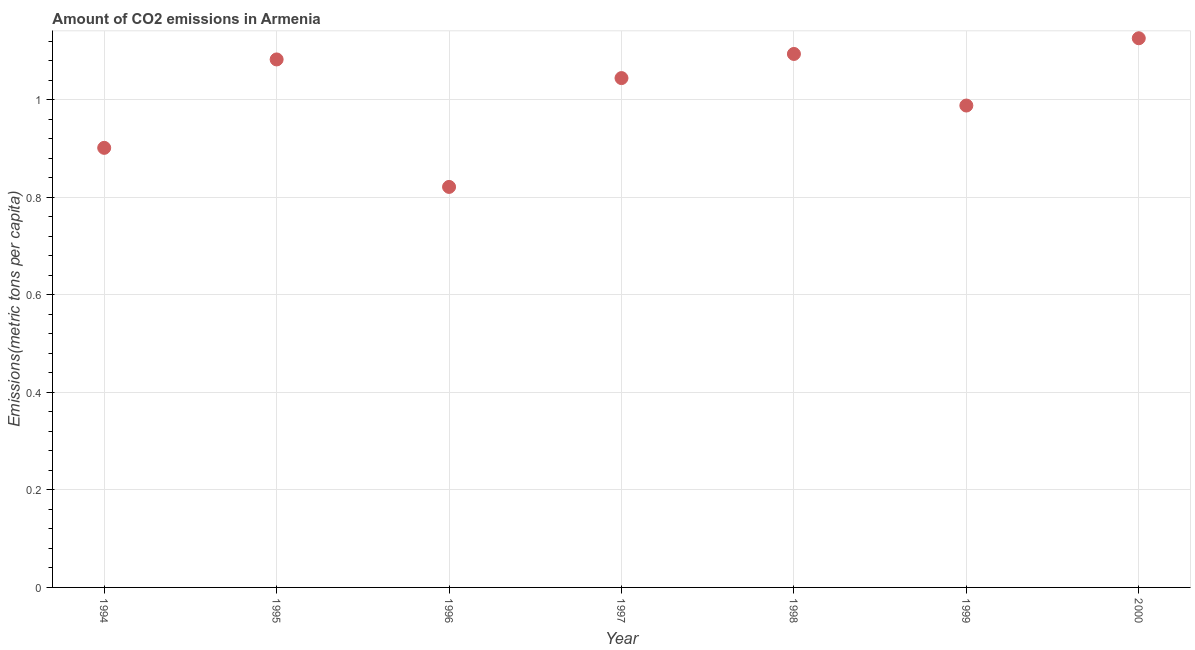What is the amount of co2 emissions in 1998?
Make the answer very short. 1.09. Across all years, what is the maximum amount of co2 emissions?
Make the answer very short. 1.13. Across all years, what is the minimum amount of co2 emissions?
Keep it short and to the point. 0.82. What is the sum of the amount of co2 emissions?
Provide a short and direct response. 7.06. What is the difference between the amount of co2 emissions in 1995 and 1999?
Provide a short and direct response. 0.09. What is the average amount of co2 emissions per year?
Your answer should be compact. 1.01. What is the median amount of co2 emissions?
Offer a very short reply. 1.04. In how many years, is the amount of co2 emissions greater than 0.36 metric tons per capita?
Keep it short and to the point. 7. Do a majority of the years between 1997 and 1995 (inclusive) have amount of co2 emissions greater than 0.04 metric tons per capita?
Give a very brief answer. No. What is the ratio of the amount of co2 emissions in 1998 to that in 1999?
Make the answer very short. 1.11. Is the amount of co2 emissions in 1996 less than that in 2000?
Provide a short and direct response. Yes. Is the difference between the amount of co2 emissions in 1995 and 1996 greater than the difference between any two years?
Make the answer very short. No. What is the difference between the highest and the second highest amount of co2 emissions?
Offer a terse response. 0.03. Is the sum of the amount of co2 emissions in 1995 and 1998 greater than the maximum amount of co2 emissions across all years?
Keep it short and to the point. Yes. What is the difference between the highest and the lowest amount of co2 emissions?
Provide a succinct answer. 0.3. In how many years, is the amount of co2 emissions greater than the average amount of co2 emissions taken over all years?
Keep it short and to the point. 4. Does the amount of co2 emissions monotonically increase over the years?
Offer a terse response. No. How many dotlines are there?
Provide a succinct answer. 1. What is the difference between two consecutive major ticks on the Y-axis?
Provide a short and direct response. 0.2. Does the graph contain grids?
Offer a very short reply. Yes. What is the title of the graph?
Give a very brief answer. Amount of CO2 emissions in Armenia. What is the label or title of the Y-axis?
Provide a succinct answer. Emissions(metric tons per capita). What is the Emissions(metric tons per capita) in 1994?
Provide a short and direct response. 0.9. What is the Emissions(metric tons per capita) in 1995?
Your answer should be very brief. 1.08. What is the Emissions(metric tons per capita) in 1996?
Offer a very short reply. 0.82. What is the Emissions(metric tons per capita) in 1997?
Make the answer very short. 1.04. What is the Emissions(metric tons per capita) in 1998?
Your answer should be very brief. 1.09. What is the Emissions(metric tons per capita) in 1999?
Keep it short and to the point. 0.99. What is the Emissions(metric tons per capita) in 2000?
Offer a terse response. 1.13. What is the difference between the Emissions(metric tons per capita) in 1994 and 1995?
Provide a succinct answer. -0.18. What is the difference between the Emissions(metric tons per capita) in 1994 and 1996?
Provide a succinct answer. 0.08. What is the difference between the Emissions(metric tons per capita) in 1994 and 1997?
Provide a succinct answer. -0.14. What is the difference between the Emissions(metric tons per capita) in 1994 and 1998?
Provide a short and direct response. -0.19. What is the difference between the Emissions(metric tons per capita) in 1994 and 1999?
Provide a succinct answer. -0.09. What is the difference between the Emissions(metric tons per capita) in 1994 and 2000?
Offer a terse response. -0.22. What is the difference between the Emissions(metric tons per capita) in 1995 and 1996?
Provide a short and direct response. 0.26. What is the difference between the Emissions(metric tons per capita) in 1995 and 1997?
Give a very brief answer. 0.04. What is the difference between the Emissions(metric tons per capita) in 1995 and 1998?
Give a very brief answer. -0.01. What is the difference between the Emissions(metric tons per capita) in 1995 and 1999?
Offer a terse response. 0.09. What is the difference between the Emissions(metric tons per capita) in 1995 and 2000?
Give a very brief answer. -0.04. What is the difference between the Emissions(metric tons per capita) in 1996 and 1997?
Make the answer very short. -0.22. What is the difference between the Emissions(metric tons per capita) in 1996 and 1998?
Offer a terse response. -0.27. What is the difference between the Emissions(metric tons per capita) in 1996 and 1999?
Provide a short and direct response. -0.17. What is the difference between the Emissions(metric tons per capita) in 1996 and 2000?
Ensure brevity in your answer.  -0.3. What is the difference between the Emissions(metric tons per capita) in 1997 and 1998?
Make the answer very short. -0.05. What is the difference between the Emissions(metric tons per capita) in 1997 and 1999?
Provide a succinct answer. 0.06. What is the difference between the Emissions(metric tons per capita) in 1997 and 2000?
Your answer should be compact. -0.08. What is the difference between the Emissions(metric tons per capita) in 1998 and 1999?
Ensure brevity in your answer.  0.11. What is the difference between the Emissions(metric tons per capita) in 1998 and 2000?
Your answer should be very brief. -0.03. What is the difference between the Emissions(metric tons per capita) in 1999 and 2000?
Provide a short and direct response. -0.14. What is the ratio of the Emissions(metric tons per capita) in 1994 to that in 1995?
Provide a succinct answer. 0.83. What is the ratio of the Emissions(metric tons per capita) in 1994 to that in 1996?
Give a very brief answer. 1.1. What is the ratio of the Emissions(metric tons per capita) in 1994 to that in 1997?
Ensure brevity in your answer.  0.86. What is the ratio of the Emissions(metric tons per capita) in 1994 to that in 1998?
Keep it short and to the point. 0.82. What is the ratio of the Emissions(metric tons per capita) in 1994 to that in 1999?
Ensure brevity in your answer.  0.91. What is the ratio of the Emissions(metric tons per capita) in 1994 to that in 2000?
Make the answer very short. 0.8. What is the ratio of the Emissions(metric tons per capita) in 1995 to that in 1996?
Offer a very short reply. 1.32. What is the ratio of the Emissions(metric tons per capita) in 1995 to that in 1997?
Ensure brevity in your answer.  1.04. What is the ratio of the Emissions(metric tons per capita) in 1995 to that in 1999?
Provide a succinct answer. 1.1. What is the ratio of the Emissions(metric tons per capita) in 1996 to that in 1997?
Your answer should be very brief. 0.79. What is the ratio of the Emissions(metric tons per capita) in 1996 to that in 1998?
Make the answer very short. 0.75. What is the ratio of the Emissions(metric tons per capita) in 1996 to that in 1999?
Keep it short and to the point. 0.83. What is the ratio of the Emissions(metric tons per capita) in 1996 to that in 2000?
Your answer should be very brief. 0.73. What is the ratio of the Emissions(metric tons per capita) in 1997 to that in 1998?
Provide a short and direct response. 0.95. What is the ratio of the Emissions(metric tons per capita) in 1997 to that in 1999?
Provide a short and direct response. 1.06. What is the ratio of the Emissions(metric tons per capita) in 1997 to that in 2000?
Keep it short and to the point. 0.93. What is the ratio of the Emissions(metric tons per capita) in 1998 to that in 1999?
Ensure brevity in your answer.  1.11. What is the ratio of the Emissions(metric tons per capita) in 1999 to that in 2000?
Ensure brevity in your answer.  0.88. 